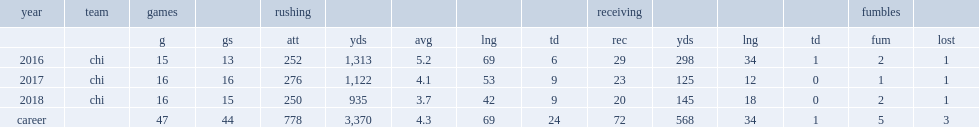How many rushing yards did howard get in 2018? 935.0. 